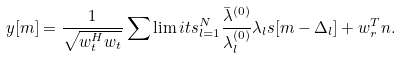Convert formula to latex. <formula><loc_0><loc_0><loc_500><loc_500>y [ m ] = \frac { 1 } { { \sqrt { { w } _ { t } ^ { H } { { w } _ { t } } } } } \sum \lim i t s _ { l = 1 } ^ { N } { \frac { { { { \bar { \lambda } } ^ { ( 0 ) } } } } { { \lambda _ { l } ^ { ( 0 ) } } } { \lambda _ { l } } s [ m - \Delta _ { l } ] } + { w } _ { r } ^ { T } { n } .</formula> 